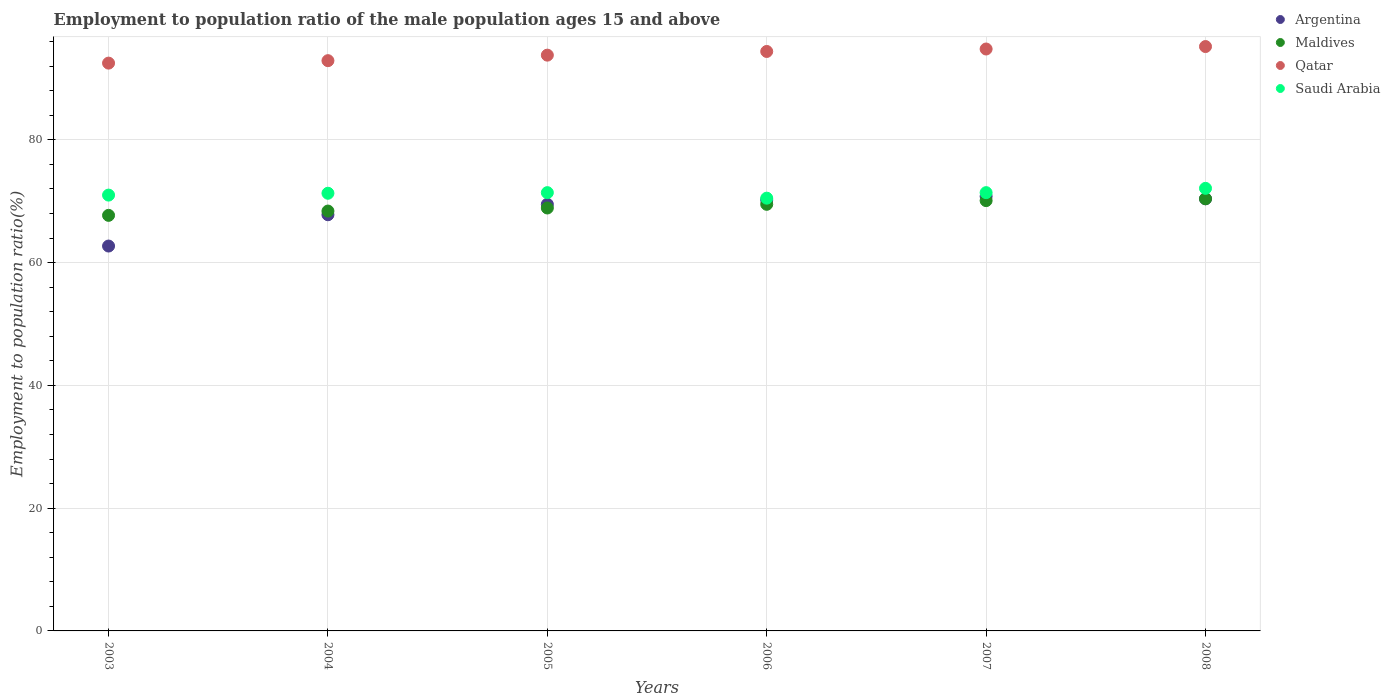Is the number of dotlines equal to the number of legend labels?
Your answer should be very brief. Yes. What is the employment to population ratio in Argentina in 2005?
Your answer should be very brief. 69.5. Across all years, what is the maximum employment to population ratio in Argentina?
Keep it short and to the point. 70.8. Across all years, what is the minimum employment to population ratio in Argentina?
Keep it short and to the point. 62.7. In which year was the employment to population ratio in Qatar minimum?
Your answer should be compact. 2003. What is the total employment to population ratio in Argentina in the graph?
Offer a very short reply. 411.4. What is the difference between the employment to population ratio in Argentina in 2003 and that in 2006?
Offer a very short reply. -7.5. What is the difference between the employment to population ratio in Maldives in 2004 and the employment to population ratio in Saudi Arabia in 2007?
Ensure brevity in your answer.  -3. What is the average employment to population ratio in Argentina per year?
Ensure brevity in your answer.  68.57. In the year 2008, what is the difference between the employment to population ratio in Argentina and employment to population ratio in Maldives?
Offer a very short reply. 0. What is the ratio of the employment to population ratio in Maldives in 2003 to that in 2008?
Give a very brief answer. 0.96. Is the difference between the employment to population ratio in Argentina in 2006 and 2007 greater than the difference between the employment to population ratio in Maldives in 2006 and 2007?
Offer a very short reply. No. What is the difference between the highest and the second highest employment to population ratio in Argentina?
Keep it short and to the point. 0.4. What is the difference between the highest and the lowest employment to population ratio in Argentina?
Keep it short and to the point. 8.1. In how many years, is the employment to population ratio in Saudi Arabia greater than the average employment to population ratio in Saudi Arabia taken over all years?
Your response must be concise. 4. Does the employment to population ratio in Argentina monotonically increase over the years?
Your answer should be very brief. No. Is the employment to population ratio in Argentina strictly less than the employment to population ratio in Qatar over the years?
Keep it short and to the point. Yes. How many dotlines are there?
Keep it short and to the point. 4. How many years are there in the graph?
Ensure brevity in your answer.  6. What is the difference between two consecutive major ticks on the Y-axis?
Give a very brief answer. 20. Are the values on the major ticks of Y-axis written in scientific E-notation?
Make the answer very short. No. How are the legend labels stacked?
Your response must be concise. Vertical. What is the title of the graph?
Provide a succinct answer. Employment to population ratio of the male population ages 15 and above. Does "Haiti" appear as one of the legend labels in the graph?
Your answer should be very brief. No. What is the label or title of the Y-axis?
Your answer should be very brief. Employment to population ratio(%). What is the Employment to population ratio(%) of Argentina in 2003?
Keep it short and to the point. 62.7. What is the Employment to population ratio(%) in Maldives in 2003?
Your answer should be compact. 67.7. What is the Employment to population ratio(%) of Qatar in 2003?
Ensure brevity in your answer.  92.5. What is the Employment to population ratio(%) of Saudi Arabia in 2003?
Your response must be concise. 71. What is the Employment to population ratio(%) of Argentina in 2004?
Provide a short and direct response. 67.8. What is the Employment to population ratio(%) in Maldives in 2004?
Offer a very short reply. 68.4. What is the Employment to population ratio(%) of Qatar in 2004?
Provide a short and direct response. 92.9. What is the Employment to population ratio(%) in Saudi Arabia in 2004?
Make the answer very short. 71.3. What is the Employment to population ratio(%) in Argentina in 2005?
Make the answer very short. 69.5. What is the Employment to population ratio(%) in Maldives in 2005?
Ensure brevity in your answer.  68.9. What is the Employment to population ratio(%) of Qatar in 2005?
Your answer should be very brief. 93.8. What is the Employment to population ratio(%) of Saudi Arabia in 2005?
Ensure brevity in your answer.  71.4. What is the Employment to population ratio(%) in Argentina in 2006?
Ensure brevity in your answer.  70.2. What is the Employment to population ratio(%) of Maldives in 2006?
Give a very brief answer. 69.5. What is the Employment to population ratio(%) in Qatar in 2006?
Provide a short and direct response. 94.4. What is the Employment to population ratio(%) in Saudi Arabia in 2006?
Provide a short and direct response. 70.5. What is the Employment to population ratio(%) of Argentina in 2007?
Give a very brief answer. 70.8. What is the Employment to population ratio(%) of Maldives in 2007?
Give a very brief answer. 70.1. What is the Employment to population ratio(%) in Qatar in 2007?
Keep it short and to the point. 94.8. What is the Employment to population ratio(%) of Saudi Arabia in 2007?
Make the answer very short. 71.4. What is the Employment to population ratio(%) of Argentina in 2008?
Ensure brevity in your answer.  70.4. What is the Employment to population ratio(%) of Maldives in 2008?
Offer a terse response. 70.4. What is the Employment to population ratio(%) in Qatar in 2008?
Provide a short and direct response. 95.2. What is the Employment to population ratio(%) of Saudi Arabia in 2008?
Offer a terse response. 72.1. Across all years, what is the maximum Employment to population ratio(%) in Argentina?
Make the answer very short. 70.8. Across all years, what is the maximum Employment to population ratio(%) of Maldives?
Make the answer very short. 70.4. Across all years, what is the maximum Employment to population ratio(%) in Qatar?
Your response must be concise. 95.2. Across all years, what is the maximum Employment to population ratio(%) in Saudi Arabia?
Your response must be concise. 72.1. Across all years, what is the minimum Employment to population ratio(%) in Argentina?
Ensure brevity in your answer.  62.7. Across all years, what is the minimum Employment to population ratio(%) of Maldives?
Provide a succinct answer. 67.7. Across all years, what is the minimum Employment to population ratio(%) of Qatar?
Your answer should be very brief. 92.5. Across all years, what is the minimum Employment to population ratio(%) of Saudi Arabia?
Give a very brief answer. 70.5. What is the total Employment to population ratio(%) of Argentina in the graph?
Offer a terse response. 411.4. What is the total Employment to population ratio(%) of Maldives in the graph?
Your answer should be compact. 415. What is the total Employment to population ratio(%) of Qatar in the graph?
Provide a short and direct response. 563.6. What is the total Employment to population ratio(%) of Saudi Arabia in the graph?
Keep it short and to the point. 427.7. What is the difference between the Employment to population ratio(%) in Argentina in 2003 and that in 2004?
Provide a succinct answer. -5.1. What is the difference between the Employment to population ratio(%) of Maldives in 2003 and that in 2004?
Your answer should be compact. -0.7. What is the difference between the Employment to population ratio(%) in Argentina in 2003 and that in 2005?
Provide a succinct answer. -6.8. What is the difference between the Employment to population ratio(%) of Saudi Arabia in 2003 and that in 2005?
Your answer should be very brief. -0.4. What is the difference between the Employment to population ratio(%) of Argentina in 2003 and that in 2006?
Offer a very short reply. -7.5. What is the difference between the Employment to population ratio(%) in Qatar in 2003 and that in 2006?
Your answer should be very brief. -1.9. What is the difference between the Employment to population ratio(%) of Maldives in 2003 and that in 2007?
Your answer should be very brief. -2.4. What is the difference between the Employment to population ratio(%) of Qatar in 2003 and that in 2007?
Ensure brevity in your answer.  -2.3. What is the difference between the Employment to population ratio(%) of Maldives in 2003 and that in 2008?
Your answer should be very brief. -2.7. What is the difference between the Employment to population ratio(%) in Argentina in 2004 and that in 2005?
Your response must be concise. -1.7. What is the difference between the Employment to population ratio(%) of Maldives in 2004 and that in 2005?
Ensure brevity in your answer.  -0.5. What is the difference between the Employment to population ratio(%) of Qatar in 2004 and that in 2005?
Make the answer very short. -0.9. What is the difference between the Employment to population ratio(%) of Saudi Arabia in 2004 and that in 2005?
Keep it short and to the point. -0.1. What is the difference between the Employment to population ratio(%) of Argentina in 2004 and that in 2006?
Your answer should be very brief. -2.4. What is the difference between the Employment to population ratio(%) of Qatar in 2004 and that in 2006?
Offer a terse response. -1.5. What is the difference between the Employment to population ratio(%) in Saudi Arabia in 2004 and that in 2006?
Provide a succinct answer. 0.8. What is the difference between the Employment to population ratio(%) of Maldives in 2004 and that in 2007?
Offer a terse response. -1.7. What is the difference between the Employment to population ratio(%) in Qatar in 2004 and that in 2007?
Provide a succinct answer. -1.9. What is the difference between the Employment to population ratio(%) of Argentina in 2004 and that in 2008?
Provide a succinct answer. -2.6. What is the difference between the Employment to population ratio(%) of Maldives in 2004 and that in 2008?
Make the answer very short. -2. What is the difference between the Employment to population ratio(%) of Saudi Arabia in 2004 and that in 2008?
Your answer should be very brief. -0.8. What is the difference between the Employment to population ratio(%) in Argentina in 2005 and that in 2006?
Your response must be concise. -0.7. What is the difference between the Employment to population ratio(%) in Maldives in 2005 and that in 2007?
Make the answer very short. -1.2. What is the difference between the Employment to population ratio(%) of Argentina in 2005 and that in 2008?
Your answer should be very brief. -0.9. What is the difference between the Employment to population ratio(%) in Maldives in 2005 and that in 2008?
Offer a very short reply. -1.5. What is the difference between the Employment to population ratio(%) of Saudi Arabia in 2005 and that in 2008?
Offer a very short reply. -0.7. What is the difference between the Employment to population ratio(%) of Saudi Arabia in 2006 and that in 2007?
Keep it short and to the point. -0.9. What is the difference between the Employment to population ratio(%) of Argentina in 2006 and that in 2008?
Offer a very short reply. -0.2. What is the difference between the Employment to population ratio(%) of Maldives in 2006 and that in 2008?
Your answer should be very brief. -0.9. What is the difference between the Employment to population ratio(%) of Saudi Arabia in 2006 and that in 2008?
Give a very brief answer. -1.6. What is the difference between the Employment to population ratio(%) of Qatar in 2007 and that in 2008?
Provide a short and direct response. -0.4. What is the difference between the Employment to population ratio(%) in Argentina in 2003 and the Employment to population ratio(%) in Qatar in 2004?
Give a very brief answer. -30.2. What is the difference between the Employment to population ratio(%) in Argentina in 2003 and the Employment to population ratio(%) in Saudi Arabia in 2004?
Offer a terse response. -8.6. What is the difference between the Employment to population ratio(%) of Maldives in 2003 and the Employment to population ratio(%) of Qatar in 2004?
Your answer should be compact. -25.2. What is the difference between the Employment to population ratio(%) in Qatar in 2003 and the Employment to population ratio(%) in Saudi Arabia in 2004?
Ensure brevity in your answer.  21.2. What is the difference between the Employment to population ratio(%) of Argentina in 2003 and the Employment to population ratio(%) of Maldives in 2005?
Provide a short and direct response. -6.2. What is the difference between the Employment to population ratio(%) of Argentina in 2003 and the Employment to population ratio(%) of Qatar in 2005?
Make the answer very short. -31.1. What is the difference between the Employment to population ratio(%) of Maldives in 2003 and the Employment to population ratio(%) of Qatar in 2005?
Your answer should be very brief. -26.1. What is the difference between the Employment to population ratio(%) of Maldives in 2003 and the Employment to population ratio(%) of Saudi Arabia in 2005?
Keep it short and to the point. -3.7. What is the difference between the Employment to population ratio(%) of Qatar in 2003 and the Employment to population ratio(%) of Saudi Arabia in 2005?
Ensure brevity in your answer.  21.1. What is the difference between the Employment to population ratio(%) of Argentina in 2003 and the Employment to population ratio(%) of Maldives in 2006?
Your answer should be compact. -6.8. What is the difference between the Employment to population ratio(%) of Argentina in 2003 and the Employment to population ratio(%) of Qatar in 2006?
Your answer should be very brief. -31.7. What is the difference between the Employment to population ratio(%) in Argentina in 2003 and the Employment to population ratio(%) in Saudi Arabia in 2006?
Your answer should be compact. -7.8. What is the difference between the Employment to population ratio(%) in Maldives in 2003 and the Employment to population ratio(%) in Qatar in 2006?
Provide a succinct answer. -26.7. What is the difference between the Employment to population ratio(%) in Maldives in 2003 and the Employment to population ratio(%) in Saudi Arabia in 2006?
Your answer should be very brief. -2.8. What is the difference between the Employment to population ratio(%) of Argentina in 2003 and the Employment to population ratio(%) of Maldives in 2007?
Provide a succinct answer. -7.4. What is the difference between the Employment to population ratio(%) of Argentina in 2003 and the Employment to population ratio(%) of Qatar in 2007?
Your answer should be very brief. -32.1. What is the difference between the Employment to population ratio(%) in Argentina in 2003 and the Employment to population ratio(%) in Saudi Arabia in 2007?
Provide a short and direct response. -8.7. What is the difference between the Employment to population ratio(%) of Maldives in 2003 and the Employment to population ratio(%) of Qatar in 2007?
Make the answer very short. -27.1. What is the difference between the Employment to population ratio(%) of Qatar in 2003 and the Employment to population ratio(%) of Saudi Arabia in 2007?
Provide a short and direct response. 21.1. What is the difference between the Employment to population ratio(%) in Argentina in 2003 and the Employment to population ratio(%) in Maldives in 2008?
Your answer should be compact. -7.7. What is the difference between the Employment to population ratio(%) in Argentina in 2003 and the Employment to population ratio(%) in Qatar in 2008?
Make the answer very short. -32.5. What is the difference between the Employment to population ratio(%) of Argentina in 2003 and the Employment to population ratio(%) of Saudi Arabia in 2008?
Give a very brief answer. -9.4. What is the difference between the Employment to population ratio(%) in Maldives in 2003 and the Employment to population ratio(%) in Qatar in 2008?
Offer a terse response. -27.5. What is the difference between the Employment to population ratio(%) in Maldives in 2003 and the Employment to population ratio(%) in Saudi Arabia in 2008?
Make the answer very short. -4.4. What is the difference between the Employment to population ratio(%) of Qatar in 2003 and the Employment to population ratio(%) of Saudi Arabia in 2008?
Your answer should be very brief. 20.4. What is the difference between the Employment to population ratio(%) of Argentina in 2004 and the Employment to population ratio(%) of Maldives in 2005?
Offer a very short reply. -1.1. What is the difference between the Employment to population ratio(%) in Maldives in 2004 and the Employment to population ratio(%) in Qatar in 2005?
Your response must be concise. -25.4. What is the difference between the Employment to population ratio(%) of Maldives in 2004 and the Employment to population ratio(%) of Saudi Arabia in 2005?
Your answer should be compact. -3. What is the difference between the Employment to population ratio(%) of Qatar in 2004 and the Employment to population ratio(%) of Saudi Arabia in 2005?
Make the answer very short. 21.5. What is the difference between the Employment to population ratio(%) in Argentina in 2004 and the Employment to population ratio(%) in Qatar in 2006?
Offer a terse response. -26.6. What is the difference between the Employment to population ratio(%) in Argentina in 2004 and the Employment to population ratio(%) in Saudi Arabia in 2006?
Offer a very short reply. -2.7. What is the difference between the Employment to population ratio(%) in Maldives in 2004 and the Employment to population ratio(%) in Qatar in 2006?
Offer a terse response. -26. What is the difference between the Employment to population ratio(%) of Maldives in 2004 and the Employment to population ratio(%) of Saudi Arabia in 2006?
Your answer should be compact. -2.1. What is the difference between the Employment to population ratio(%) in Qatar in 2004 and the Employment to population ratio(%) in Saudi Arabia in 2006?
Your answer should be compact. 22.4. What is the difference between the Employment to population ratio(%) of Maldives in 2004 and the Employment to population ratio(%) of Qatar in 2007?
Your response must be concise. -26.4. What is the difference between the Employment to population ratio(%) in Argentina in 2004 and the Employment to population ratio(%) in Maldives in 2008?
Offer a terse response. -2.6. What is the difference between the Employment to population ratio(%) in Argentina in 2004 and the Employment to population ratio(%) in Qatar in 2008?
Provide a short and direct response. -27.4. What is the difference between the Employment to population ratio(%) in Argentina in 2004 and the Employment to population ratio(%) in Saudi Arabia in 2008?
Keep it short and to the point. -4.3. What is the difference between the Employment to population ratio(%) in Maldives in 2004 and the Employment to population ratio(%) in Qatar in 2008?
Your answer should be very brief. -26.8. What is the difference between the Employment to population ratio(%) in Maldives in 2004 and the Employment to population ratio(%) in Saudi Arabia in 2008?
Keep it short and to the point. -3.7. What is the difference between the Employment to population ratio(%) in Qatar in 2004 and the Employment to population ratio(%) in Saudi Arabia in 2008?
Your response must be concise. 20.8. What is the difference between the Employment to population ratio(%) of Argentina in 2005 and the Employment to population ratio(%) of Maldives in 2006?
Provide a short and direct response. 0. What is the difference between the Employment to population ratio(%) of Argentina in 2005 and the Employment to population ratio(%) of Qatar in 2006?
Give a very brief answer. -24.9. What is the difference between the Employment to population ratio(%) of Maldives in 2005 and the Employment to population ratio(%) of Qatar in 2006?
Keep it short and to the point. -25.5. What is the difference between the Employment to population ratio(%) of Maldives in 2005 and the Employment to population ratio(%) of Saudi Arabia in 2006?
Offer a very short reply. -1.6. What is the difference between the Employment to population ratio(%) in Qatar in 2005 and the Employment to population ratio(%) in Saudi Arabia in 2006?
Your response must be concise. 23.3. What is the difference between the Employment to population ratio(%) of Argentina in 2005 and the Employment to population ratio(%) of Qatar in 2007?
Make the answer very short. -25.3. What is the difference between the Employment to population ratio(%) in Argentina in 2005 and the Employment to population ratio(%) in Saudi Arabia in 2007?
Your answer should be compact. -1.9. What is the difference between the Employment to population ratio(%) in Maldives in 2005 and the Employment to population ratio(%) in Qatar in 2007?
Give a very brief answer. -25.9. What is the difference between the Employment to population ratio(%) in Maldives in 2005 and the Employment to population ratio(%) in Saudi Arabia in 2007?
Offer a terse response. -2.5. What is the difference between the Employment to population ratio(%) in Qatar in 2005 and the Employment to population ratio(%) in Saudi Arabia in 2007?
Provide a short and direct response. 22.4. What is the difference between the Employment to population ratio(%) of Argentina in 2005 and the Employment to population ratio(%) of Qatar in 2008?
Provide a short and direct response. -25.7. What is the difference between the Employment to population ratio(%) in Argentina in 2005 and the Employment to population ratio(%) in Saudi Arabia in 2008?
Provide a succinct answer. -2.6. What is the difference between the Employment to population ratio(%) in Maldives in 2005 and the Employment to population ratio(%) in Qatar in 2008?
Your response must be concise. -26.3. What is the difference between the Employment to population ratio(%) in Maldives in 2005 and the Employment to population ratio(%) in Saudi Arabia in 2008?
Keep it short and to the point. -3.2. What is the difference between the Employment to population ratio(%) in Qatar in 2005 and the Employment to population ratio(%) in Saudi Arabia in 2008?
Provide a short and direct response. 21.7. What is the difference between the Employment to population ratio(%) of Argentina in 2006 and the Employment to population ratio(%) of Qatar in 2007?
Ensure brevity in your answer.  -24.6. What is the difference between the Employment to population ratio(%) of Maldives in 2006 and the Employment to population ratio(%) of Qatar in 2007?
Ensure brevity in your answer.  -25.3. What is the difference between the Employment to population ratio(%) in Qatar in 2006 and the Employment to population ratio(%) in Saudi Arabia in 2007?
Provide a short and direct response. 23. What is the difference between the Employment to population ratio(%) in Argentina in 2006 and the Employment to population ratio(%) in Saudi Arabia in 2008?
Make the answer very short. -1.9. What is the difference between the Employment to population ratio(%) in Maldives in 2006 and the Employment to population ratio(%) in Qatar in 2008?
Your response must be concise. -25.7. What is the difference between the Employment to population ratio(%) of Maldives in 2006 and the Employment to population ratio(%) of Saudi Arabia in 2008?
Your answer should be compact. -2.6. What is the difference between the Employment to population ratio(%) in Qatar in 2006 and the Employment to population ratio(%) in Saudi Arabia in 2008?
Provide a short and direct response. 22.3. What is the difference between the Employment to population ratio(%) of Argentina in 2007 and the Employment to population ratio(%) of Maldives in 2008?
Your response must be concise. 0.4. What is the difference between the Employment to population ratio(%) of Argentina in 2007 and the Employment to population ratio(%) of Qatar in 2008?
Give a very brief answer. -24.4. What is the difference between the Employment to population ratio(%) of Maldives in 2007 and the Employment to population ratio(%) of Qatar in 2008?
Provide a succinct answer. -25.1. What is the difference between the Employment to population ratio(%) in Qatar in 2007 and the Employment to population ratio(%) in Saudi Arabia in 2008?
Your response must be concise. 22.7. What is the average Employment to population ratio(%) of Argentina per year?
Provide a succinct answer. 68.57. What is the average Employment to population ratio(%) of Maldives per year?
Provide a succinct answer. 69.17. What is the average Employment to population ratio(%) of Qatar per year?
Offer a very short reply. 93.93. What is the average Employment to population ratio(%) of Saudi Arabia per year?
Provide a succinct answer. 71.28. In the year 2003, what is the difference between the Employment to population ratio(%) of Argentina and Employment to population ratio(%) of Maldives?
Your answer should be very brief. -5. In the year 2003, what is the difference between the Employment to population ratio(%) in Argentina and Employment to population ratio(%) in Qatar?
Your answer should be compact. -29.8. In the year 2003, what is the difference between the Employment to population ratio(%) of Argentina and Employment to population ratio(%) of Saudi Arabia?
Your response must be concise. -8.3. In the year 2003, what is the difference between the Employment to population ratio(%) in Maldives and Employment to population ratio(%) in Qatar?
Ensure brevity in your answer.  -24.8. In the year 2003, what is the difference between the Employment to population ratio(%) of Qatar and Employment to population ratio(%) of Saudi Arabia?
Offer a terse response. 21.5. In the year 2004, what is the difference between the Employment to population ratio(%) of Argentina and Employment to population ratio(%) of Maldives?
Keep it short and to the point. -0.6. In the year 2004, what is the difference between the Employment to population ratio(%) of Argentina and Employment to population ratio(%) of Qatar?
Provide a short and direct response. -25.1. In the year 2004, what is the difference between the Employment to population ratio(%) of Argentina and Employment to population ratio(%) of Saudi Arabia?
Provide a short and direct response. -3.5. In the year 2004, what is the difference between the Employment to population ratio(%) of Maldives and Employment to population ratio(%) of Qatar?
Provide a short and direct response. -24.5. In the year 2004, what is the difference between the Employment to population ratio(%) in Qatar and Employment to population ratio(%) in Saudi Arabia?
Offer a very short reply. 21.6. In the year 2005, what is the difference between the Employment to population ratio(%) of Argentina and Employment to population ratio(%) of Maldives?
Provide a short and direct response. 0.6. In the year 2005, what is the difference between the Employment to population ratio(%) of Argentina and Employment to population ratio(%) of Qatar?
Your answer should be compact. -24.3. In the year 2005, what is the difference between the Employment to population ratio(%) of Maldives and Employment to population ratio(%) of Qatar?
Your response must be concise. -24.9. In the year 2005, what is the difference between the Employment to population ratio(%) in Qatar and Employment to population ratio(%) in Saudi Arabia?
Your answer should be very brief. 22.4. In the year 2006, what is the difference between the Employment to population ratio(%) in Argentina and Employment to population ratio(%) in Qatar?
Your answer should be compact. -24.2. In the year 2006, what is the difference between the Employment to population ratio(%) in Argentina and Employment to population ratio(%) in Saudi Arabia?
Provide a short and direct response. -0.3. In the year 2006, what is the difference between the Employment to population ratio(%) of Maldives and Employment to population ratio(%) of Qatar?
Your answer should be compact. -24.9. In the year 2006, what is the difference between the Employment to population ratio(%) of Maldives and Employment to population ratio(%) of Saudi Arabia?
Keep it short and to the point. -1. In the year 2006, what is the difference between the Employment to population ratio(%) of Qatar and Employment to population ratio(%) of Saudi Arabia?
Ensure brevity in your answer.  23.9. In the year 2007, what is the difference between the Employment to population ratio(%) in Argentina and Employment to population ratio(%) in Maldives?
Your answer should be compact. 0.7. In the year 2007, what is the difference between the Employment to population ratio(%) in Argentina and Employment to population ratio(%) in Qatar?
Provide a succinct answer. -24. In the year 2007, what is the difference between the Employment to population ratio(%) in Maldives and Employment to population ratio(%) in Qatar?
Provide a short and direct response. -24.7. In the year 2007, what is the difference between the Employment to population ratio(%) in Maldives and Employment to population ratio(%) in Saudi Arabia?
Give a very brief answer. -1.3. In the year 2007, what is the difference between the Employment to population ratio(%) in Qatar and Employment to population ratio(%) in Saudi Arabia?
Offer a very short reply. 23.4. In the year 2008, what is the difference between the Employment to population ratio(%) in Argentina and Employment to population ratio(%) in Qatar?
Provide a succinct answer. -24.8. In the year 2008, what is the difference between the Employment to population ratio(%) of Argentina and Employment to population ratio(%) of Saudi Arabia?
Ensure brevity in your answer.  -1.7. In the year 2008, what is the difference between the Employment to population ratio(%) in Maldives and Employment to population ratio(%) in Qatar?
Offer a very short reply. -24.8. In the year 2008, what is the difference between the Employment to population ratio(%) in Maldives and Employment to population ratio(%) in Saudi Arabia?
Provide a short and direct response. -1.7. In the year 2008, what is the difference between the Employment to population ratio(%) of Qatar and Employment to population ratio(%) of Saudi Arabia?
Your response must be concise. 23.1. What is the ratio of the Employment to population ratio(%) in Argentina in 2003 to that in 2004?
Offer a very short reply. 0.92. What is the ratio of the Employment to population ratio(%) in Qatar in 2003 to that in 2004?
Your answer should be compact. 1. What is the ratio of the Employment to population ratio(%) in Argentina in 2003 to that in 2005?
Your answer should be compact. 0.9. What is the ratio of the Employment to population ratio(%) of Maldives in 2003 to that in 2005?
Offer a very short reply. 0.98. What is the ratio of the Employment to population ratio(%) of Qatar in 2003 to that in 2005?
Give a very brief answer. 0.99. What is the ratio of the Employment to population ratio(%) in Saudi Arabia in 2003 to that in 2005?
Ensure brevity in your answer.  0.99. What is the ratio of the Employment to population ratio(%) of Argentina in 2003 to that in 2006?
Keep it short and to the point. 0.89. What is the ratio of the Employment to population ratio(%) of Maldives in 2003 to that in 2006?
Give a very brief answer. 0.97. What is the ratio of the Employment to population ratio(%) of Qatar in 2003 to that in 2006?
Provide a succinct answer. 0.98. What is the ratio of the Employment to population ratio(%) in Saudi Arabia in 2003 to that in 2006?
Your answer should be compact. 1.01. What is the ratio of the Employment to population ratio(%) in Argentina in 2003 to that in 2007?
Offer a terse response. 0.89. What is the ratio of the Employment to population ratio(%) in Maldives in 2003 to that in 2007?
Ensure brevity in your answer.  0.97. What is the ratio of the Employment to population ratio(%) of Qatar in 2003 to that in 2007?
Your answer should be compact. 0.98. What is the ratio of the Employment to population ratio(%) in Argentina in 2003 to that in 2008?
Offer a terse response. 0.89. What is the ratio of the Employment to population ratio(%) in Maldives in 2003 to that in 2008?
Your answer should be compact. 0.96. What is the ratio of the Employment to population ratio(%) of Qatar in 2003 to that in 2008?
Provide a short and direct response. 0.97. What is the ratio of the Employment to population ratio(%) in Saudi Arabia in 2003 to that in 2008?
Provide a succinct answer. 0.98. What is the ratio of the Employment to population ratio(%) in Argentina in 2004 to that in 2005?
Provide a short and direct response. 0.98. What is the ratio of the Employment to population ratio(%) in Saudi Arabia in 2004 to that in 2005?
Your response must be concise. 1. What is the ratio of the Employment to population ratio(%) in Argentina in 2004 to that in 2006?
Give a very brief answer. 0.97. What is the ratio of the Employment to population ratio(%) of Maldives in 2004 to that in 2006?
Offer a terse response. 0.98. What is the ratio of the Employment to population ratio(%) in Qatar in 2004 to that in 2006?
Make the answer very short. 0.98. What is the ratio of the Employment to population ratio(%) of Saudi Arabia in 2004 to that in 2006?
Your response must be concise. 1.01. What is the ratio of the Employment to population ratio(%) in Argentina in 2004 to that in 2007?
Keep it short and to the point. 0.96. What is the ratio of the Employment to population ratio(%) in Maldives in 2004 to that in 2007?
Your response must be concise. 0.98. What is the ratio of the Employment to population ratio(%) of Qatar in 2004 to that in 2007?
Offer a terse response. 0.98. What is the ratio of the Employment to population ratio(%) of Saudi Arabia in 2004 to that in 2007?
Keep it short and to the point. 1. What is the ratio of the Employment to population ratio(%) of Argentina in 2004 to that in 2008?
Give a very brief answer. 0.96. What is the ratio of the Employment to population ratio(%) in Maldives in 2004 to that in 2008?
Provide a short and direct response. 0.97. What is the ratio of the Employment to population ratio(%) of Qatar in 2004 to that in 2008?
Your response must be concise. 0.98. What is the ratio of the Employment to population ratio(%) in Saudi Arabia in 2004 to that in 2008?
Ensure brevity in your answer.  0.99. What is the ratio of the Employment to population ratio(%) of Qatar in 2005 to that in 2006?
Your answer should be very brief. 0.99. What is the ratio of the Employment to population ratio(%) in Saudi Arabia in 2005 to that in 2006?
Keep it short and to the point. 1.01. What is the ratio of the Employment to population ratio(%) in Argentina in 2005 to that in 2007?
Provide a short and direct response. 0.98. What is the ratio of the Employment to population ratio(%) of Maldives in 2005 to that in 2007?
Offer a terse response. 0.98. What is the ratio of the Employment to population ratio(%) of Saudi Arabia in 2005 to that in 2007?
Offer a very short reply. 1. What is the ratio of the Employment to population ratio(%) in Argentina in 2005 to that in 2008?
Provide a succinct answer. 0.99. What is the ratio of the Employment to population ratio(%) of Maldives in 2005 to that in 2008?
Keep it short and to the point. 0.98. What is the ratio of the Employment to population ratio(%) in Qatar in 2005 to that in 2008?
Ensure brevity in your answer.  0.99. What is the ratio of the Employment to population ratio(%) in Saudi Arabia in 2005 to that in 2008?
Provide a short and direct response. 0.99. What is the ratio of the Employment to population ratio(%) in Saudi Arabia in 2006 to that in 2007?
Give a very brief answer. 0.99. What is the ratio of the Employment to population ratio(%) of Argentina in 2006 to that in 2008?
Give a very brief answer. 1. What is the ratio of the Employment to population ratio(%) in Maldives in 2006 to that in 2008?
Provide a short and direct response. 0.99. What is the ratio of the Employment to population ratio(%) of Qatar in 2006 to that in 2008?
Provide a short and direct response. 0.99. What is the ratio of the Employment to population ratio(%) of Saudi Arabia in 2006 to that in 2008?
Ensure brevity in your answer.  0.98. What is the ratio of the Employment to population ratio(%) of Argentina in 2007 to that in 2008?
Your answer should be very brief. 1.01. What is the ratio of the Employment to population ratio(%) of Maldives in 2007 to that in 2008?
Keep it short and to the point. 1. What is the ratio of the Employment to population ratio(%) in Qatar in 2007 to that in 2008?
Ensure brevity in your answer.  1. What is the ratio of the Employment to population ratio(%) of Saudi Arabia in 2007 to that in 2008?
Your answer should be compact. 0.99. What is the difference between the highest and the second highest Employment to population ratio(%) in Argentina?
Provide a short and direct response. 0.4. What is the difference between the highest and the second highest Employment to population ratio(%) of Maldives?
Ensure brevity in your answer.  0.3. What is the difference between the highest and the second highest Employment to population ratio(%) in Saudi Arabia?
Offer a very short reply. 0.7. What is the difference between the highest and the lowest Employment to population ratio(%) in Argentina?
Make the answer very short. 8.1. 